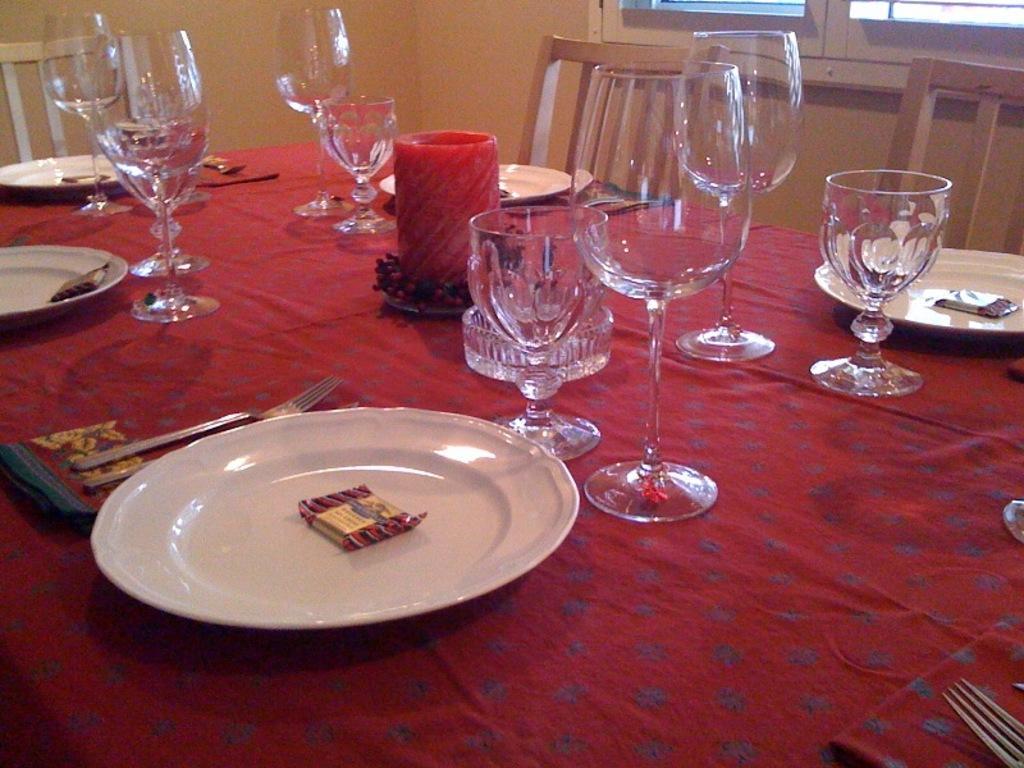Can you describe this image briefly? In the middle of the image there is a table on the table there are some plates, glasses, spoons, forks. Surrounding the table there are few chairs. Behind the chairs there's a wall. Top right side of the image there is a window. 